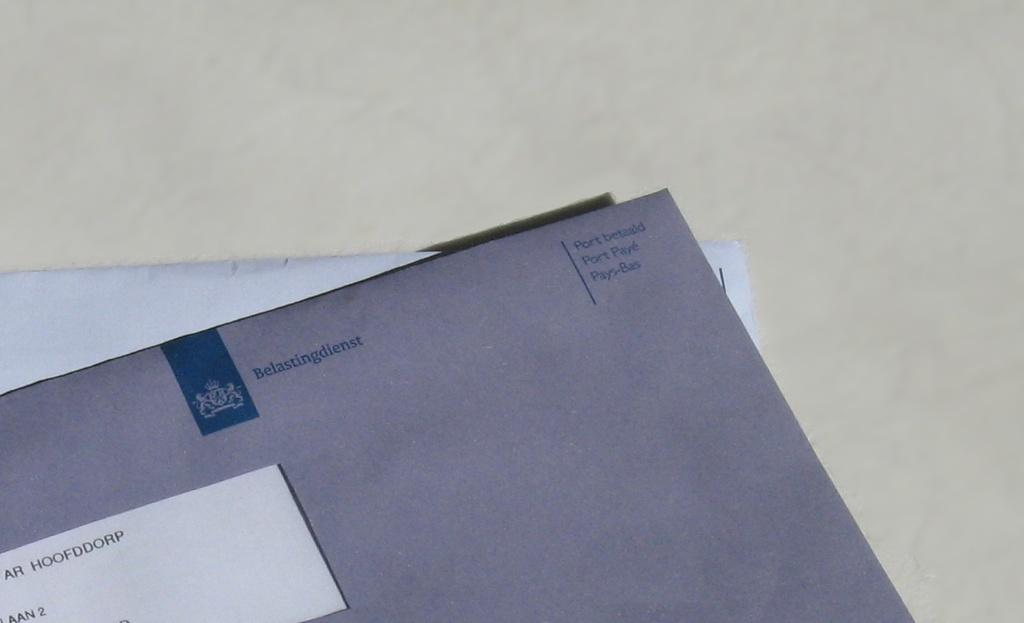<image>
Present a compact description of the photo's key features. A gray envelope containing mail with a foreign language written at the top that says Belastingienst. 